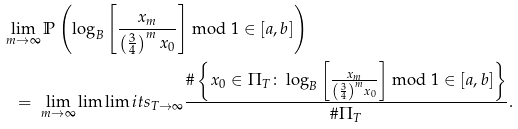Convert formula to latex. <formula><loc_0><loc_0><loc_500><loc_500>& \lim _ { m \rightarrow \infty } \mathbb { P } \left ( \log _ { B } \left [ \frac { x _ { m } } { \left ( \frac { 3 } { 4 } \right ) ^ { m } x _ { 0 } } \right ] \bmod 1 \in [ a , b ] \right ) \\ & \ \ = \ \lim _ { m \rightarrow \infty } \lim \lim i t s _ { T \rightarrow \infty } \frac { \# \left \{ x _ { 0 } \in \Pi _ { T } \colon \log _ { B } \left [ \frac { x _ { m } } { \left ( \frac { 3 } { 4 } \right ) ^ { m } x _ { 0 } } \right ] \bmod 1 \in [ a , b ] \right \} } { \# \Pi _ { T } } .</formula> 